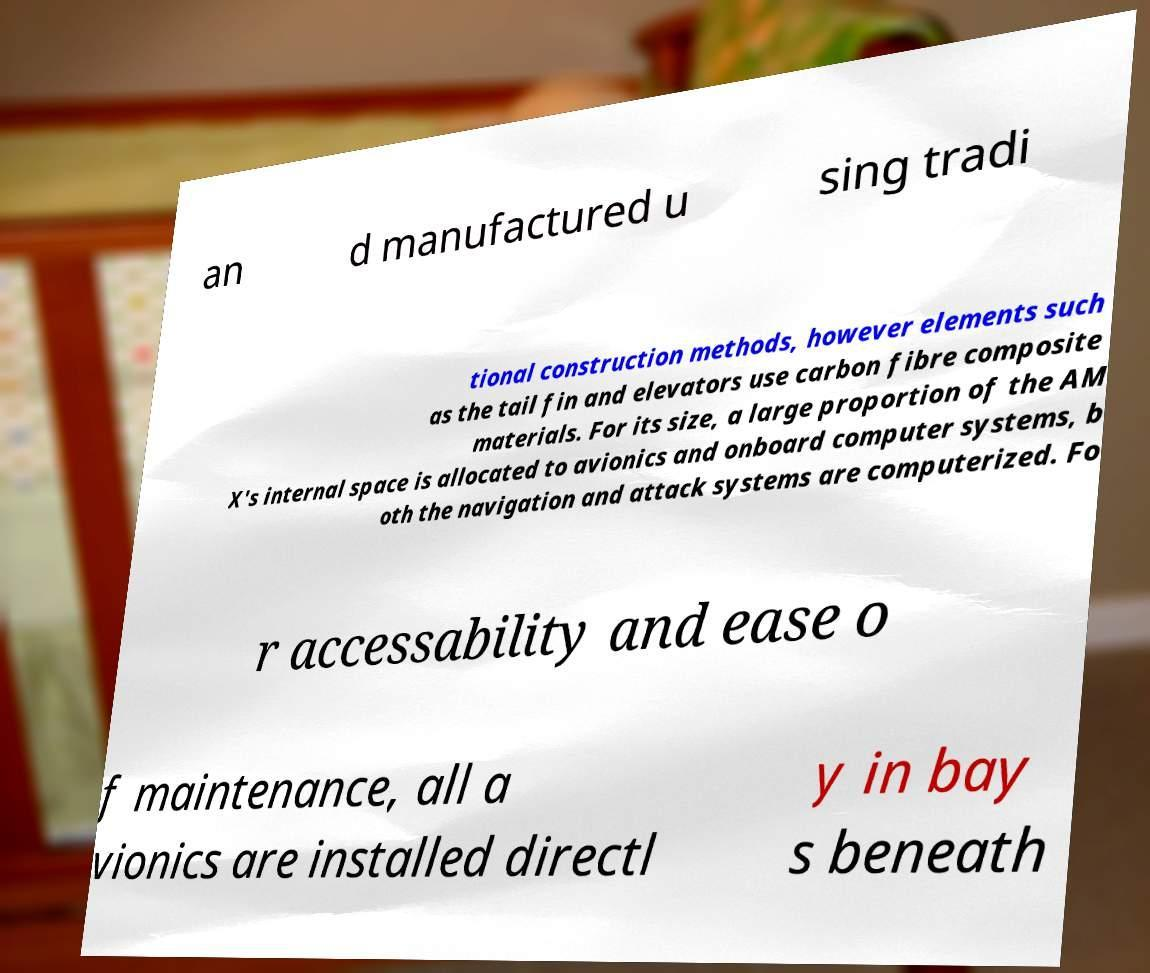Could you assist in decoding the text presented in this image and type it out clearly? an d manufactured u sing tradi tional construction methods, however elements such as the tail fin and elevators use carbon fibre composite materials. For its size, a large proportion of the AM X's internal space is allocated to avionics and onboard computer systems, b oth the navigation and attack systems are computerized. Fo r accessability and ease o f maintenance, all a vionics are installed directl y in bay s beneath 